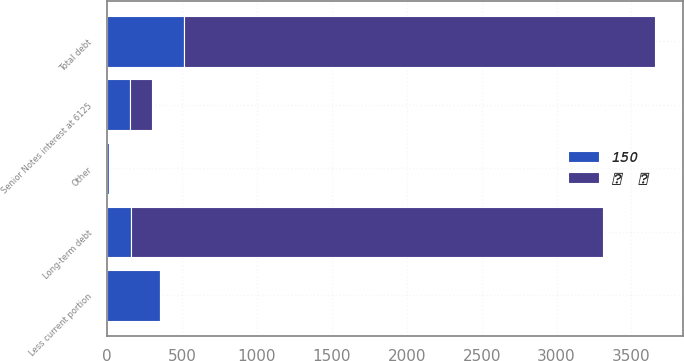Convert chart to OTSL. <chart><loc_0><loc_0><loc_500><loc_500><stacked_bar_chart><ecel><fcel>Senior Notes interest at 6125<fcel>Other<fcel>Total debt<fcel>Less current portion<fcel>Long-term debt<nl><fcel>  <fcel>151<fcel>7<fcel>3149<fcel>1<fcel>3148<nl><fcel>150<fcel>151<fcel>9<fcel>510<fcel>351<fcel>159<nl></chart> 